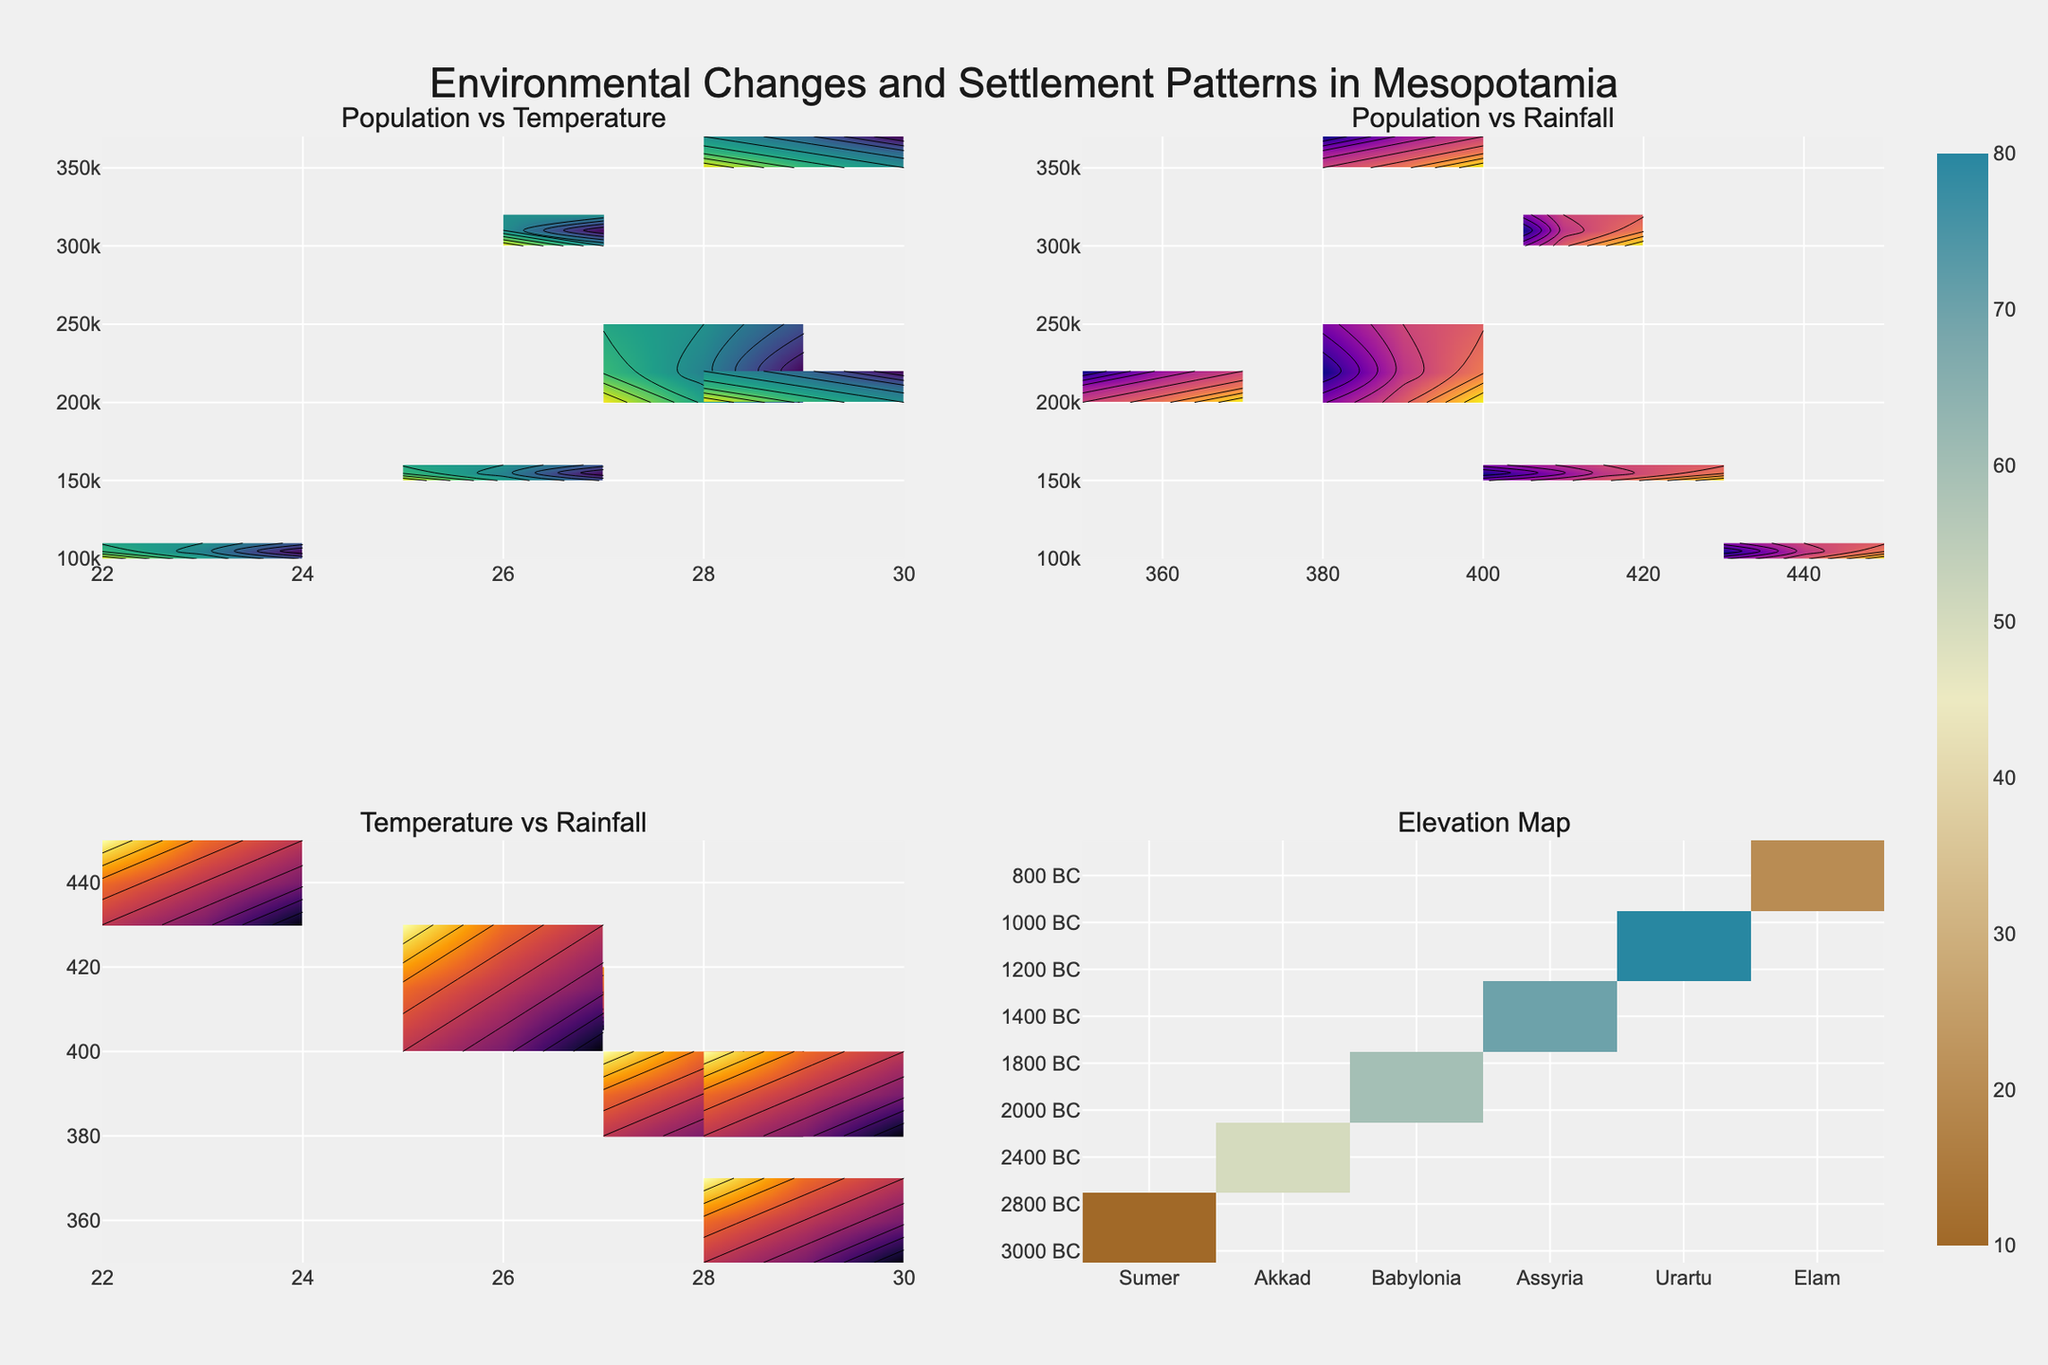What is the title of the figure? The title is prominently displayed at the top of the figure. It helps to understand the overall topic being visualized.
Answer: Environmental Changes and Settlement Patterns in Mesopotamia How many subplots are there in the figure? The figure is divided into multiple sections, each representing a different visualization. Count these divisions.
Answer: 4 Which region shows the lowest elevation according to the heatmap? Look at the bottom-right subplot labeled 'Elevation Map' and identify the region with the lowest value on the color scale.
Answer: Sumer What years are covered in the dataset for the Akkad region in the 'Population vs. Temperature' plot? Locate the 'Population vs Temperature' subplot and observe the years associated with the Akkad region, typically represented as lines or points.
Answer: 2500 BC, 2400 BC, 2300 BC Which plot shows the relationship between temperature and rainfall? The subplot titles serve as a direct reference. Identify the title that describes the relationship between temperature and rainfall.
Answer: Temperature vs Rainfall Between which two subplots can you compare population changes relative to environmental factors? Identify which subplots display population data against environmental variables like temperature and rainfall. These subplots provide insight into how population changes in relation to these factors.
Answer: Population vs Temperature and Population vs Rainfall What's the temperature range shown for the Babylon region in the 'Temperature vs Rainfall' plot? Look at the subplot that compares temperature and rainfall, and identify the temperature values that correspond to the Babylon region.
Answer: 28 to 30 degrees Which region experienced the most change in population across the years? Compare the regions in the subplots that show population against time to see which one has the largest variation.
Answer: Babylonia How does elevation vary between Assyria and Urartu? Compare the elevation data for Assyria and Urartu in the 'Elevation Map' subplot to see how their elevations differ visually.
Answer: Assyria has lower elevations than Urartu What is the primary environmental factor affecting the Urartu region? Look at the subplots and determine which environmental variable (temperature, rainfall, or elevation) shows significant variation for the Urartu region.
Answer: High rainfall 